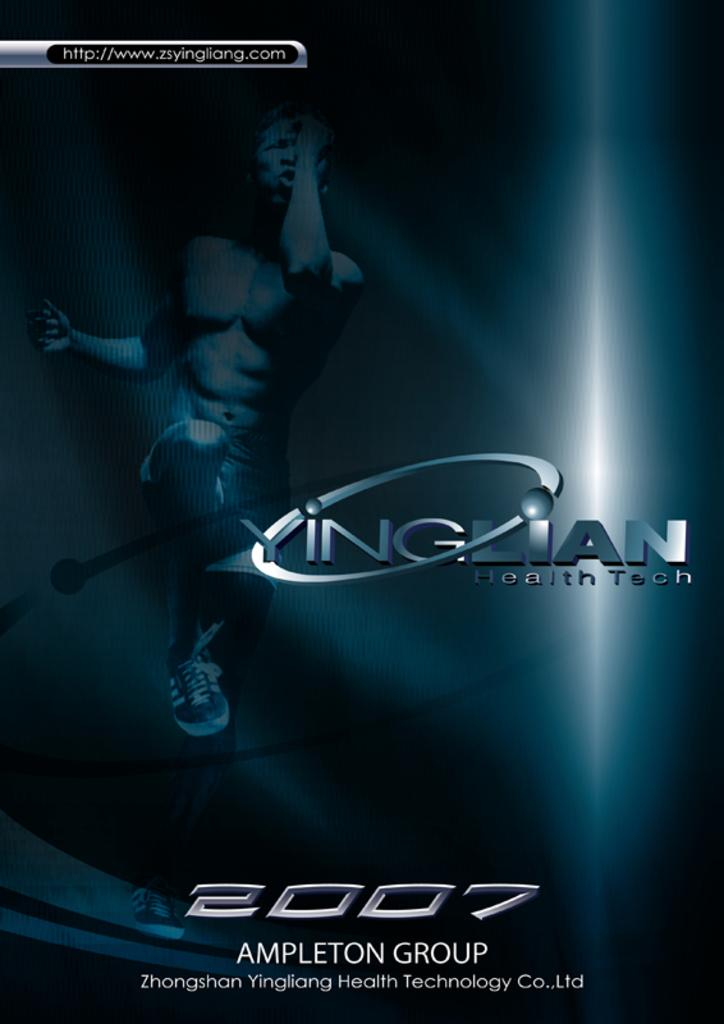<image>
Write a terse but informative summary of the picture. A case with the words 2007 Ampleton group on it. 